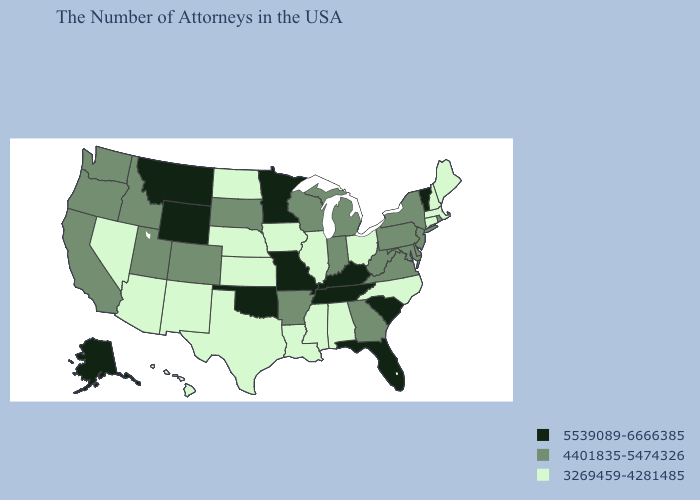What is the value of Louisiana?
Short answer required. 3269459-4281485. Does Mississippi have the lowest value in the South?
Give a very brief answer. Yes. Which states hav the highest value in the MidWest?
Short answer required. Missouri, Minnesota. Does Virginia have a lower value than Pennsylvania?
Be succinct. No. Does South Carolina have the lowest value in the South?
Short answer required. No. Which states have the highest value in the USA?
Write a very short answer. Vermont, South Carolina, Florida, Kentucky, Tennessee, Missouri, Minnesota, Oklahoma, Wyoming, Montana, Alaska. Does Oregon have the highest value in the USA?
Concise answer only. No. What is the lowest value in the Northeast?
Keep it brief. 3269459-4281485. Which states hav the highest value in the MidWest?
Quick response, please. Missouri, Minnesota. Name the states that have a value in the range 5539089-6666385?
Be succinct. Vermont, South Carolina, Florida, Kentucky, Tennessee, Missouri, Minnesota, Oklahoma, Wyoming, Montana, Alaska. Name the states that have a value in the range 3269459-4281485?
Answer briefly. Maine, Massachusetts, New Hampshire, Connecticut, North Carolina, Ohio, Alabama, Illinois, Mississippi, Louisiana, Iowa, Kansas, Nebraska, Texas, North Dakota, New Mexico, Arizona, Nevada, Hawaii. Does the first symbol in the legend represent the smallest category?
Be succinct. No. What is the value of Rhode Island?
Give a very brief answer. 4401835-5474326. Does Montana have the highest value in the USA?
Be succinct. Yes. 